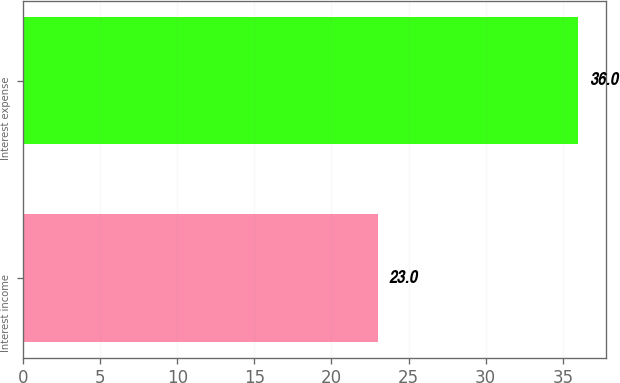Convert chart to OTSL. <chart><loc_0><loc_0><loc_500><loc_500><bar_chart><fcel>Interest income<fcel>Interest expense<nl><fcel>23<fcel>36<nl></chart> 